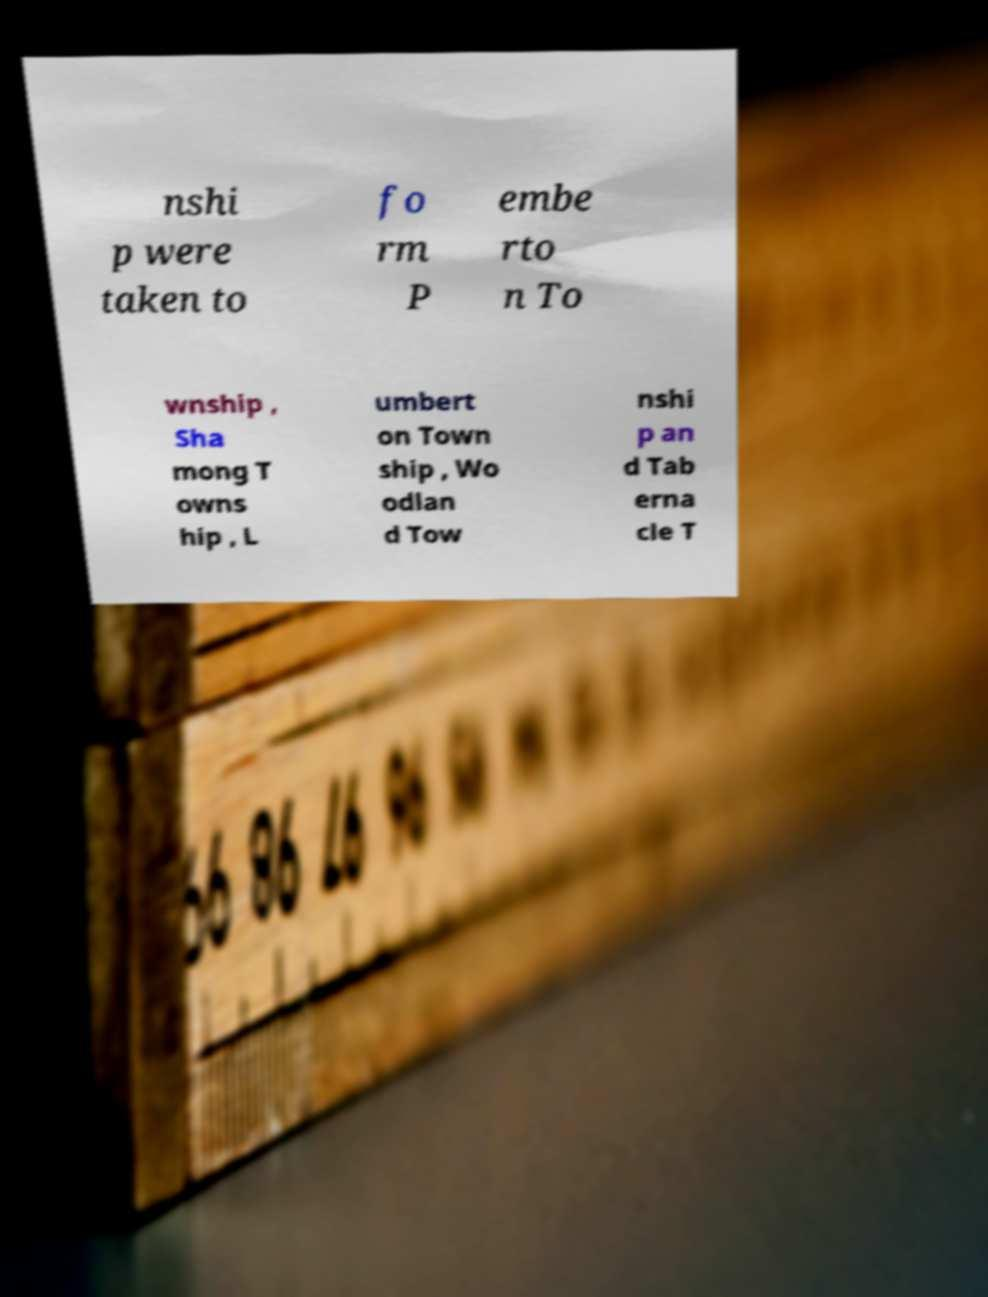Could you assist in decoding the text presented in this image and type it out clearly? nshi p were taken to fo rm P embe rto n To wnship , Sha mong T owns hip , L umbert on Town ship , Wo odlan d Tow nshi p an d Tab erna cle T 